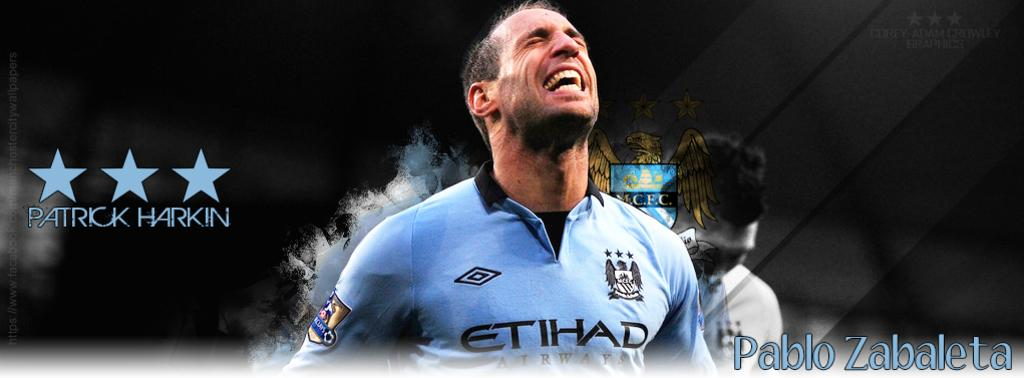<image>
Give a short and clear explanation of the subsequent image. The Etihad player has his eyes closed and his mouth open. 